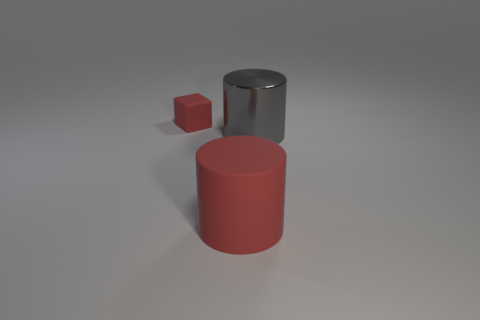What is the material of the cylinder that is the same color as the tiny thing?
Keep it short and to the point. Rubber. What size is the rubber object that is the same color as the matte cube?
Ensure brevity in your answer.  Large. Is there any other thing of the same color as the rubber cylinder?
Ensure brevity in your answer.  Yes. Are there any large red rubber objects of the same shape as the tiny object?
Provide a short and direct response. No. Is the shiny object the same shape as the large red matte object?
Your response must be concise. Yes. How many large things are red matte blocks or yellow cubes?
Your response must be concise. 0. Are there more tiny blue metallic spheres than tiny rubber things?
Give a very brief answer. No. The cube that is the same material as the large red cylinder is what size?
Give a very brief answer. Small. There is a object in front of the big gray shiny thing; is its size the same as the matte object behind the big metallic thing?
Your answer should be very brief. No. What number of objects are red rubber things on the right side of the small matte cube or small gray metal cylinders?
Your answer should be very brief. 1. 